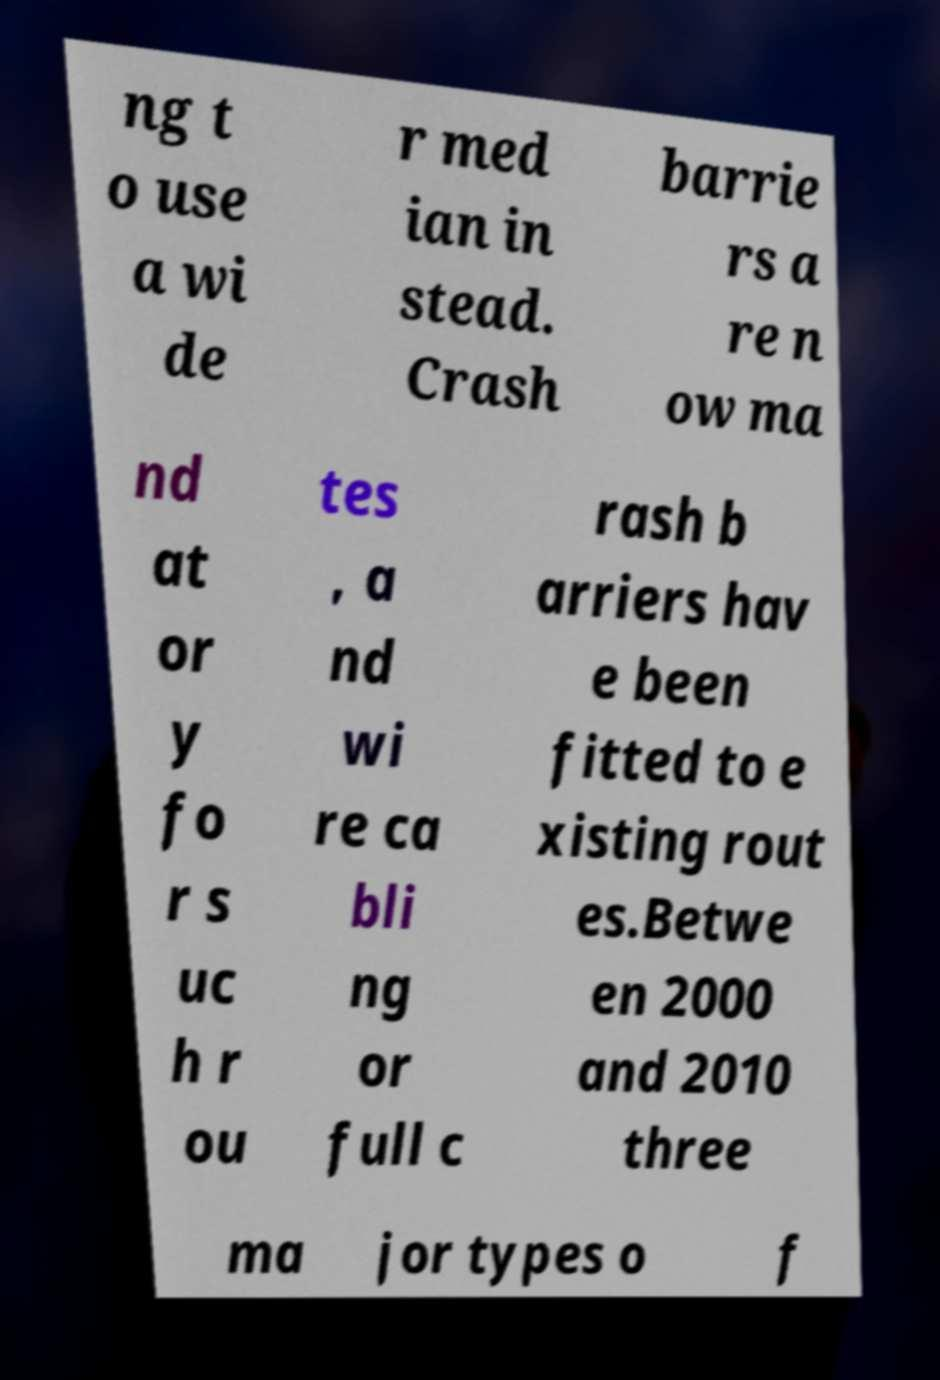Please read and relay the text visible in this image. What does it say? ng t o use a wi de r med ian in stead. Crash barrie rs a re n ow ma nd at or y fo r s uc h r ou tes , a nd wi re ca bli ng or full c rash b arriers hav e been fitted to e xisting rout es.Betwe en 2000 and 2010 three ma jor types o f 